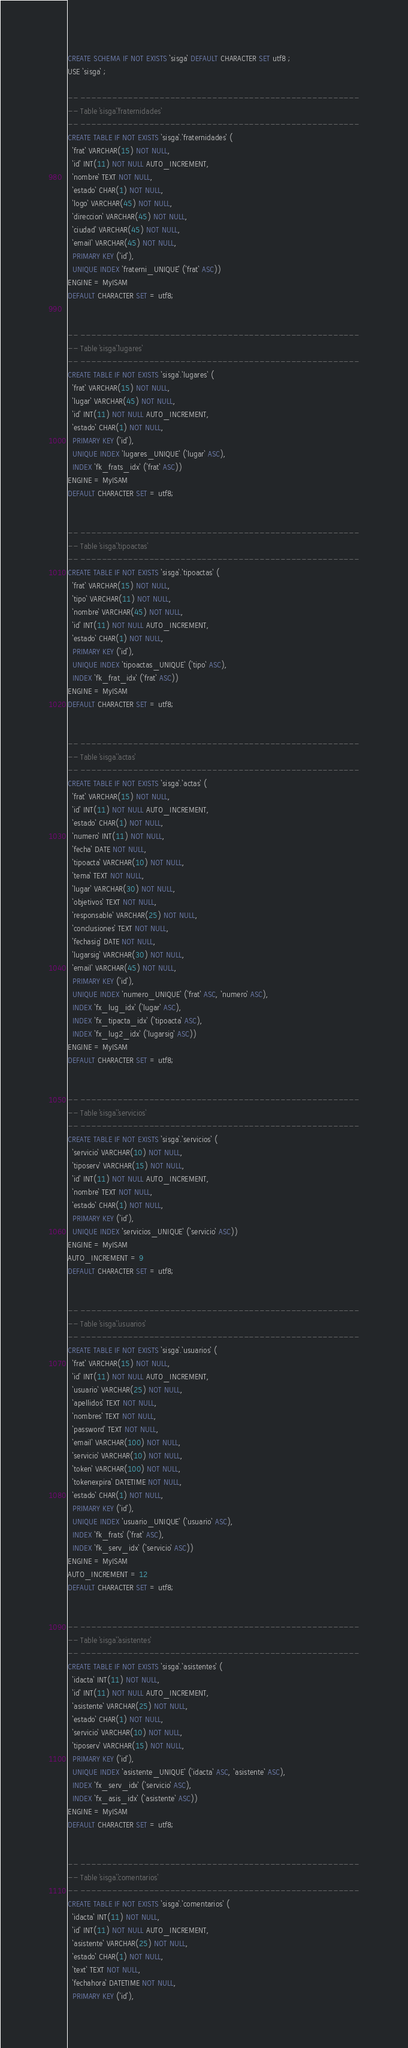<code> <loc_0><loc_0><loc_500><loc_500><_SQL_>CREATE SCHEMA IF NOT EXISTS `sisga` DEFAULT CHARACTER SET utf8 ;
USE `sisga` ;

-- -----------------------------------------------------
-- Table `sisga`.`fraternidades`
-- -----------------------------------------------------
CREATE TABLE IF NOT EXISTS `sisga`.`fraternidades` (
  `frat` VARCHAR(15) NOT NULL,
  `id` INT(11) NOT NULL AUTO_INCREMENT,
  `nombre` TEXT NOT NULL,
  `estado` CHAR(1) NOT NULL,
  `logo` VARCHAR(45) NOT NULL,
  `direccion` VARCHAR(45) NOT NULL,
  `ciudad` VARCHAR(45) NOT NULL,
  `email` VARCHAR(45) NOT NULL,
  PRIMARY KEY (`id`),
  UNIQUE INDEX `fraterni_UNIQUE` (`frat` ASC))
ENGINE = MyISAM
DEFAULT CHARACTER SET = utf8;


-- -----------------------------------------------------
-- Table `sisga`.`lugares`
-- -----------------------------------------------------
CREATE TABLE IF NOT EXISTS `sisga`.`lugares` (
  `frat` VARCHAR(15) NOT NULL,
  `lugar` VARCHAR(45) NOT NULL,
  `id` INT(11) NOT NULL AUTO_INCREMENT,
  `estado` CHAR(1) NOT NULL,
  PRIMARY KEY (`id`),
  UNIQUE INDEX `lugares_UNIQUE` (`lugar` ASC),
  INDEX `fk_frats_idx` (`frat` ASC))
ENGINE = MyISAM
DEFAULT CHARACTER SET = utf8;


-- -----------------------------------------------------
-- Table `sisga`.`tipoactas`
-- -----------------------------------------------------
CREATE TABLE IF NOT EXISTS `sisga`.`tipoactas` (
  `frat` VARCHAR(15) NOT NULL,
  `tipo` VARCHAR(11) NOT NULL,
  `nombre` VARCHAR(45) NOT NULL,
  `id` INT(11) NOT NULL AUTO_INCREMENT,
  `estado` CHAR(1) NOT NULL,
  PRIMARY KEY (`id`),
  UNIQUE INDEX `tipoactas_UNIQUE` (`tipo` ASC),
  INDEX `fk_frat_idx` (`frat` ASC))
ENGINE = MyISAM
DEFAULT CHARACTER SET = utf8;


-- -----------------------------------------------------
-- Table `sisga`.`actas`
-- -----------------------------------------------------
CREATE TABLE IF NOT EXISTS `sisga`.`actas` (
  `frat` VARCHAR(15) NOT NULL,
  `id` INT(11) NOT NULL AUTO_INCREMENT,
  `estado` CHAR(1) NOT NULL,
  `numero` INT(11) NOT NULL,
  `fecha` DATE NOT NULL,
  `tipoacta` VARCHAR(10) NOT NULL,
  `tema` TEXT NOT NULL,
  `lugar` VARCHAR(30) NOT NULL,
  `objetivos` TEXT NOT NULL,
  `responsable` VARCHAR(25) NOT NULL,
  `conclusiones` TEXT NOT NULL,
  `fechasig` DATE NOT NULL,
  `lugarsig` VARCHAR(30) NOT NULL,
  `email` VARCHAR(45) NOT NULL,
  PRIMARY KEY (`id`),
  UNIQUE INDEX `numero_UNIQUE` (`frat` ASC, `numero` ASC),
  INDEX `fx_lug_idx` (`lugar` ASC),
  INDEX `fx_tipacta_idx` (`tipoacta` ASC),
  INDEX `fx_lug2_idx` (`lugarsig` ASC))
ENGINE = MyISAM
DEFAULT CHARACTER SET = utf8;


-- -----------------------------------------------------
-- Table `sisga`.`servicios`
-- -----------------------------------------------------
CREATE TABLE IF NOT EXISTS `sisga`.`servicios` (
  `servicio` VARCHAR(10) NOT NULL,
  `tiposerv` VARCHAR(15) NOT NULL,
  `id` INT(11) NOT NULL AUTO_INCREMENT,
  `nombre` TEXT NOT NULL,
  `estado` CHAR(1) NOT NULL,
  PRIMARY KEY (`id`),
  UNIQUE INDEX `servicios_UNIQUE` (`servicio` ASC))
ENGINE = MyISAM
AUTO_INCREMENT = 9
DEFAULT CHARACTER SET = utf8;


-- -----------------------------------------------------
-- Table `sisga`.`usuarios`
-- -----------------------------------------------------
CREATE TABLE IF NOT EXISTS `sisga`.`usuarios` (
  `frat` VARCHAR(15) NOT NULL,
  `id` INT(11) NOT NULL AUTO_INCREMENT,
  `usuario` VARCHAR(25) NOT NULL,
  `apellidos` TEXT NOT NULL,
  `nombres` TEXT NOT NULL,
  `password` TEXT NOT NULL,
  `email` VARCHAR(100) NOT NULL,
  `servicio` VARCHAR(10) NOT NULL,
  `token` VARCHAR(100) NOT NULL,
  `tokenexpira` DATETIME NOT NULL,
  `estado` CHAR(1) NOT NULL,
  PRIMARY KEY (`id`),
  UNIQUE INDEX `usuario_UNIQUE` (`usuario` ASC),
  INDEX `fk_frats` (`frat` ASC),
  INDEX `fk_serv_idx` (`servicio` ASC))
ENGINE = MyISAM
AUTO_INCREMENT = 12
DEFAULT CHARACTER SET = utf8;


-- -----------------------------------------------------
-- Table `sisga`.`asistentes`
-- -----------------------------------------------------
CREATE TABLE IF NOT EXISTS `sisga`.`asistentes` (
  `idacta` INT(11) NOT NULL,
  `id` INT(11) NOT NULL AUTO_INCREMENT,
  `asistente` VARCHAR(25) NOT NULL,
  `estado` CHAR(1) NOT NULL,
  `servicio` VARCHAR(10) NOT NULL,
  `tiposerv` VARCHAR(15) NOT NULL,
  PRIMARY KEY (`id`),
  UNIQUE INDEX `asistente_UNIQUE` (`idacta` ASC, `asistente` ASC),
  INDEX `fx_serv_idx` (`servicio` ASC),
  INDEX `fx_asis_idx` (`asistente` ASC))
ENGINE = MyISAM
DEFAULT CHARACTER SET = utf8;


-- -----------------------------------------------------
-- Table `sisga`.`comentarios`
-- -----------------------------------------------------
CREATE TABLE IF NOT EXISTS `sisga`.`comentarios` (
  `idacta` INT(11) NOT NULL,
  `id` INT(11) NOT NULL AUTO_INCREMENT,
  `asistente` VARCHAR(25) NOT NULL,
  `estado` CHAR(1) NOT NULL,
  `text` TEXT NOT NULL,
  `fechahora` DATETIME NOT NULL,
  PRIMARY KEY (`id`),</code> 